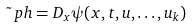<formula> <loc_0><loc_0><loc_500><loc_500>\tilde { \ } p h = D _ { x } \psi ( x , t , u , \dots , u _ { k } )</formula> 